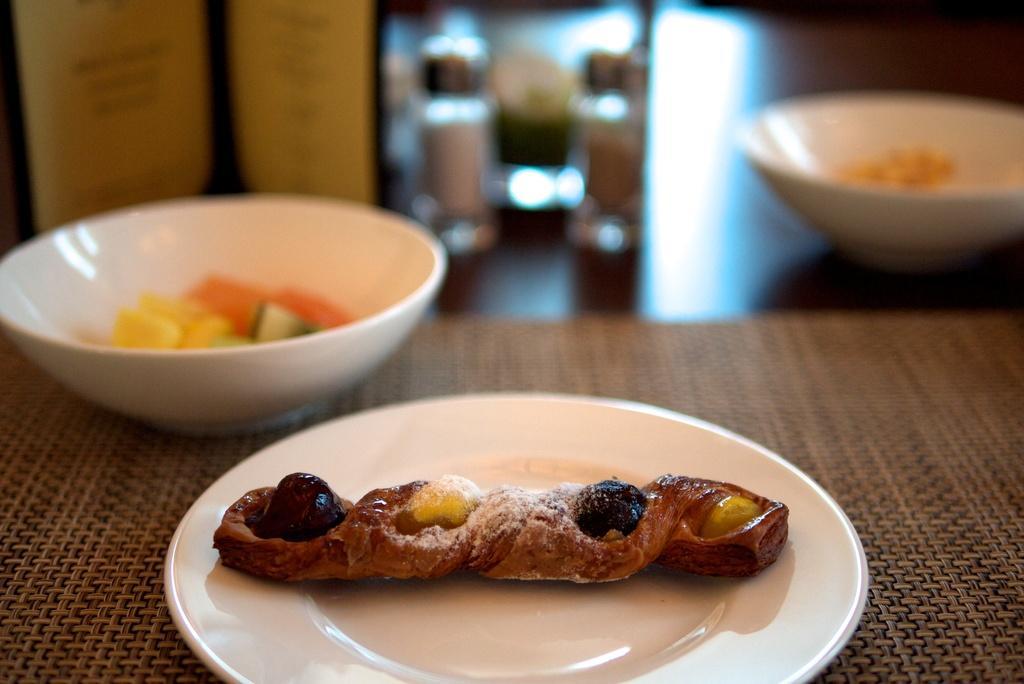In one or two sentences, can you explain what this image depicts? In this image we can see the food item on the plate, we can see the bowl on the surface, blurred background. 